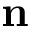Convert formula to latex. <formula><loc_0><loc_0><loc_500><loc_500>n</formula> 